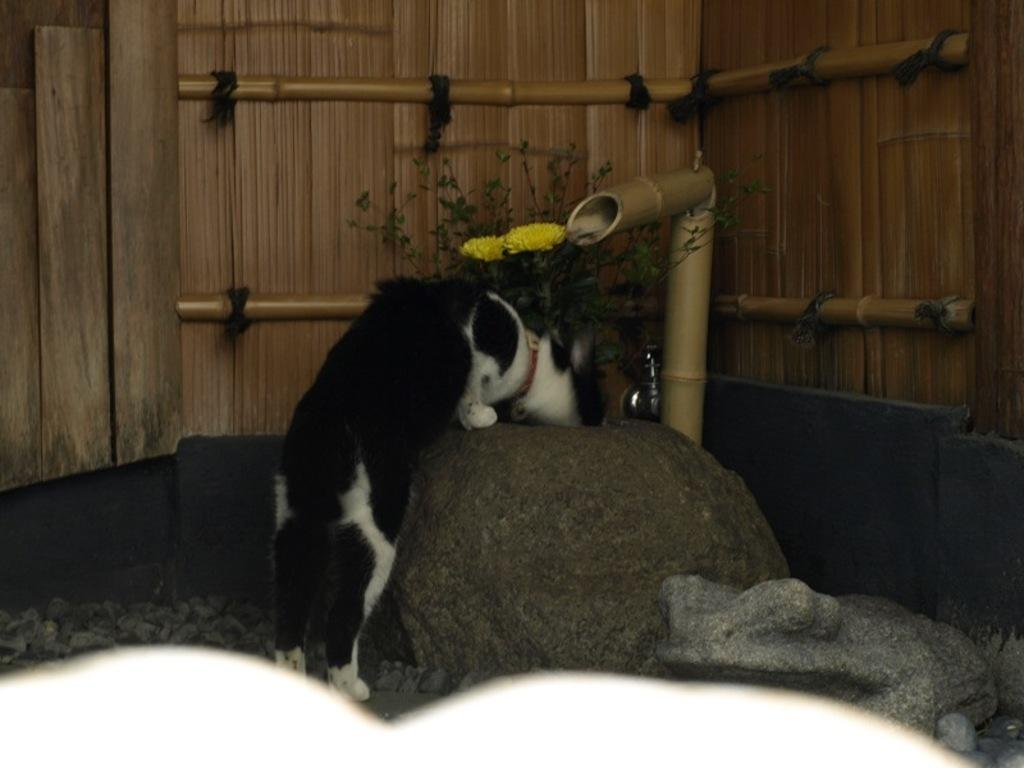What is the main subject in the middle of the image? There is a cat in the middle of the image. What type of natural elements can be seen in the image? There are rocks visible in the image. What type of structure is in the background of the image? There is a wooden fence in the background of the image. What type of plant is present in the middle of the image? There is a flower plant in the middle of the image. What type of income can be seen in the image? There is no reference to income in the image; it features a cat, rocks, a wooden fence, and a flower plant. 